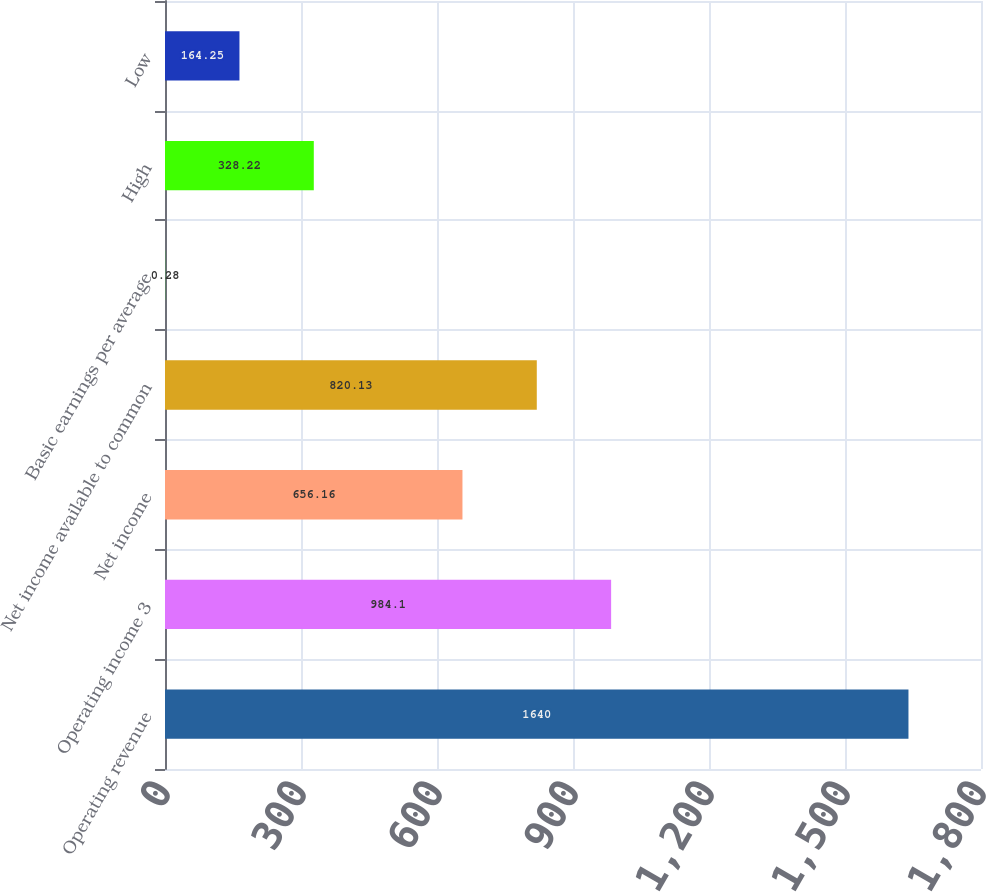Convert chart. <chart><loc_0><loc_0><loc_500><loc_500><bar_chart><fcel>Operating revenue<fcel>Operating income 3<fcel>Net income<fcel>Net income available to common<fcel>Basic earnings per average<fcel>High<fcel>Low<nl><fcel>1640<fcel>984.1<fcel>656.16<fcel>820.13<fcel>0.28<fcel>328.22<fcel>164.25<nl></chart> 